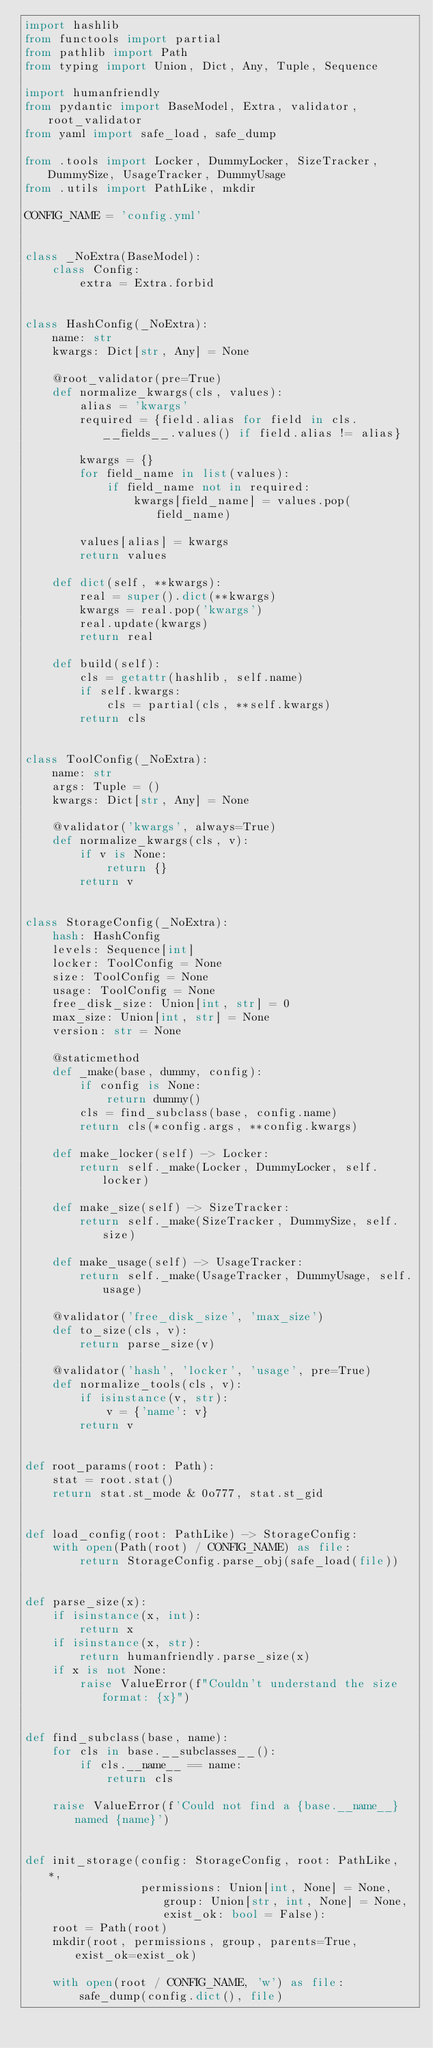Convert code to text. <code><loc_0><loc_0><loc_500><loc_500><_Python_>import hashlib
from functools import partial
from pathlib import Path
from typing import Union, Dict, Any, Tuple, Sequence

import humanfriendly
from pydantic import BaseModel, Extra, validator, root_validator
from yaml import safe_load, safe_dump

from .tools import Locker, DummyLocker, SizeTracker, DummySize, UsageTracker, DummyUsage
from .utils import PathLike, mkdir

CONFIG_NAME = 'config.yml'


class _NoExtra(BaseModel):
    class Config:
        extra = Extra.forbid


class HashConfig(_NoExtra):
    name: str
    kwargs: Dict[str, Any] = None

    @root_validator(pre=True)
    def normalize_kwargs(cls, values):
        alias = 'kwargs'
        required = {field.alias for field in cls.__fields__.values() if field.alias != alias}

        kwargs = {}
        for field_name in list(values):
            if field_name not in required:
                kwargs[field_name] = values.pop(field_name)

        values[alias] = kwargs
        return values

    def dict(self, **kwargs):
        real = super().dict(**kwargs)
        kwargs = real.pop('kwargs')
        real.update(kwargs)
        return real

    def build(self):
        cls = getattr(hashlib, self.name)
        if self.kwargs:
            cls = partial(cls, **self.kwargs)
        return cls


class ToolConfig(_NoExtra):
    name: str
    args: Tuple = ()
    kwargs: Dict[str, Any] = None

    @validator('kwargs', always=True)
    def normalize_kwargs(cls, v):
        if v is None:
            return {}
        return v


class StorageConfig(_NoExtra):
    hash: HashConfig
    levels: Sequence[int]
    locker: ToolConfig = None
    size: ToolConfig = None
    usage: ToolConfig = None
    free_disk_size: Union[int, str] = 0
    max_size: Union[int, str] = None
    version: str = None

    @staticmethod
    def _make(base, dummy, config):
        if config is None:
            return dummy()
        cls = find_subclass(base, config.name)
        return cls(*config.args, **config.kwargs)

    def make_locker(self) -> Locker:
        return self._make(Locker, DummyLocker, self.locker)

    def make_size(self) -> SizeTracker:
        return self._make(SizeTracker, DummySize, self.size)

    def make_usage(self) -> UsageTracker:
        return self._make(UsageTracker, DummyUsage, self.usage)

    @validator('free_disk_size', 'max_size')
    def to_size(cls, v):
        return parse_size(v)

    @validator('hash', 'locker', 'usage', pre=True)
    def normalize_tools(cls, v):
        if isinstance(v, str):
            v = {'name': v}
        return v


def root_params(root: Path):
    stat = root.stat()
    return stat.st_mode & 0o777, stat.st_gid


def load_config(root: PathLike) -> StorageConfig:
    with open(Path(root) / CONFIG_NAME) as file:
        return StorageConfig.parse_obj(safe_load(file))


def parse_size(x):
    if isinstance(x, int):
        return x
    if isinstance(x, str):
        return humanfriendly.parse_size(x)
    if x is not None:
        raise ValueError(f"Couldn't understand the size format: {x}")


def find_subclass(base, name):
    for cls in base.__subclasses__():
        if cls.__name__ == name:
            return cls

    raise ValueError(f'Could not find a {base.__name__} named {name}')


def init_storage(config: StorageConfig, root: PathLike, *,
                 permissions: Union[int, None] = None, group: Union[str, int, None] = None, exist_ok: bool = False):
    root = Path(root)
    mkdir(root, permissions, group, parents=True, exist_ok=exist_ok)

    with open(root / CONFIG_NAME, 'w') as file:
        safe_dump(config.dict(), file)
</code> 